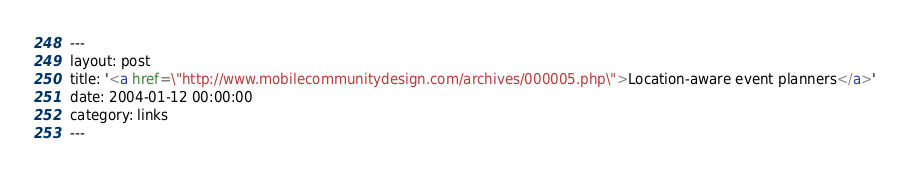<code> <loc_0><loc_0><loc_500><loc_500><_HTML_>---
layout: post
title: '<a href=\"http://www.mobilecommunitydesign.com/archives/000005.php\">Location-aware event planners</a>'
date: 2004-01-12 00:00:00
category: links
---


</code> 